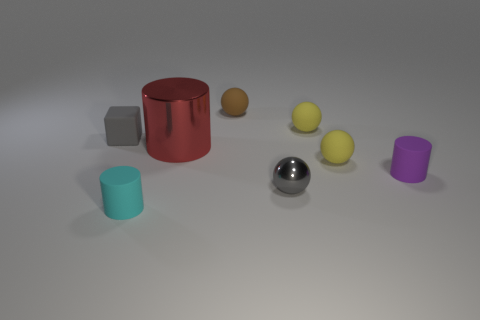What is the size of the gray thing that is the same material as the big cylinder?
Provide a succinct answer. Small. Are there any rubber things that are behind the rubber cylinder that is right of the small matte cylinder in front of the small metal sphere?
Keep it short and to the point. Yes. There is a gray object in front of the purple rubber cylinder; does it have the same size as the gray matte cube?
Ensure brevity in your answer.  Yes. What number of cyan cylinders have the same size as the block?
Offer a very short reply. 1. Do the rubber block and the metallic ball have the same color?
Ensure brevity in your answer.  Yes. There is a large object; what shape is it?
Your response must be concise. Cylinder. Are there any matte cubes that have the same color as the tiny metallic ball?
Ensure brevity in your answer.  Yes. Is the number of matte things in front of the red cylinder greater than the number of purple cylinders?
Your answer should be compact. Yes. There is a large red object; does it have the same shape as the tiny rubber object in front of the small purple cylinder?
Your answer should be very brief. Yes. Are there any tiny shiny objects?
Make the answer very short. Yes. 